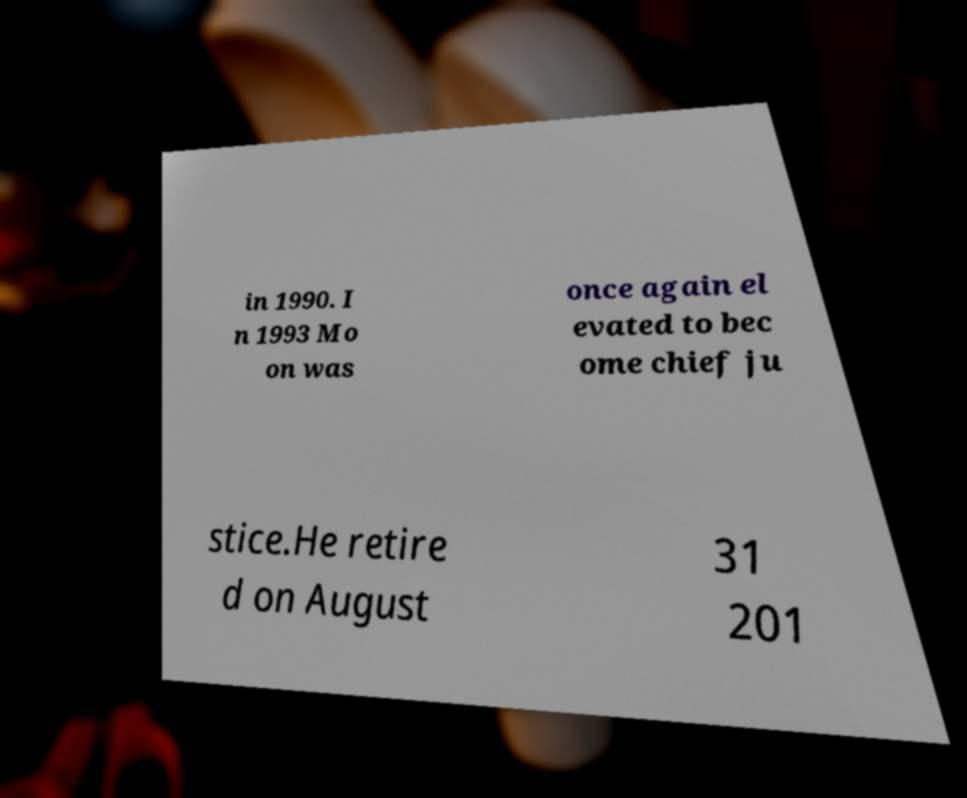Please identify and transcribe the text found in this image. in 1990. I n 1993 Mo on was once again el evated to bec ome chief ju stice.He retire d on August 31 201 